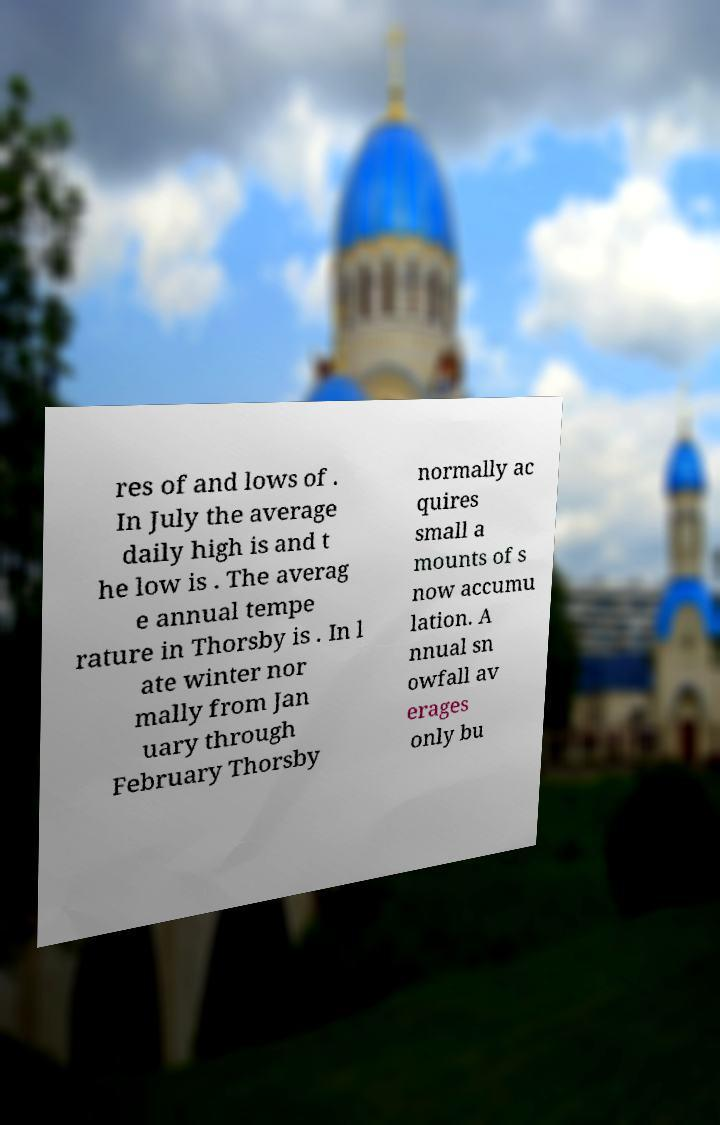Could you extract and type out the text from this image? res of and lows of . In July the average daily high is and t he low is . The averag e annual tempe rature in Thorsby is . In l ate winter nor mally from Jan uary through February Thorsby normally ac quires small a mounts of s now accumu lation. A nnual sn owfall av erages only bu 